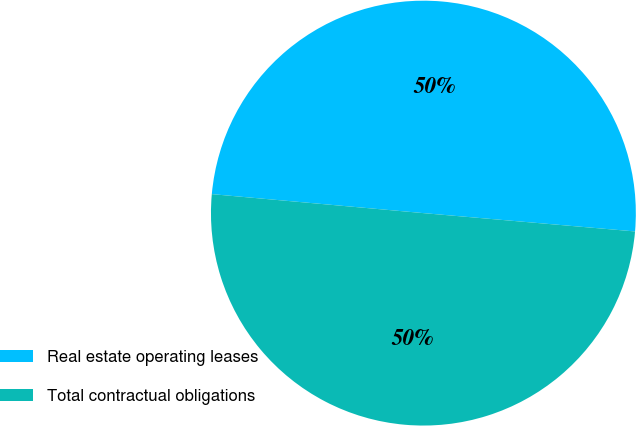Convert chart to OTSL. <chart><loc_0><loc_0><loc_500><loc_500><pie_chart><fcel>Real estate operating leases<fcel>Total contractual obligations<nl><fcel>49.95%<fcel>50.05%<nl></chart> 